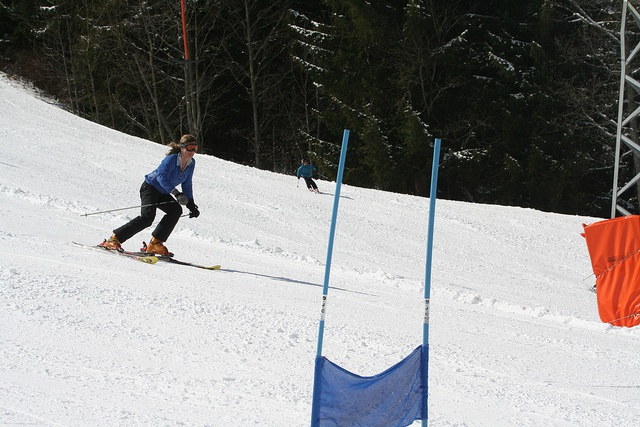Describe the objects in this image and their specific colors. I can see people in black, navy, gray, and lightgray tones, skis in black, lightgray, gray, and darkgray tones, people in black, darkblue, blue, and gray tones, and skis in black, darkgray, gray, and lightgray tones in this image. 